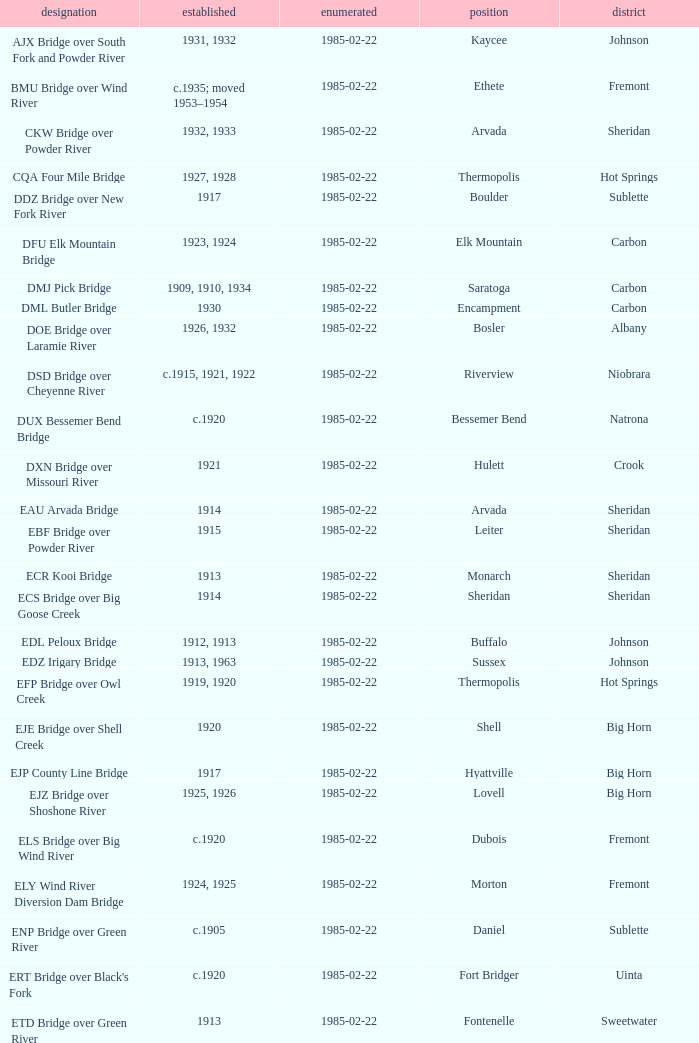In what year was the bridge in Lovell built? 1925, 1926. 